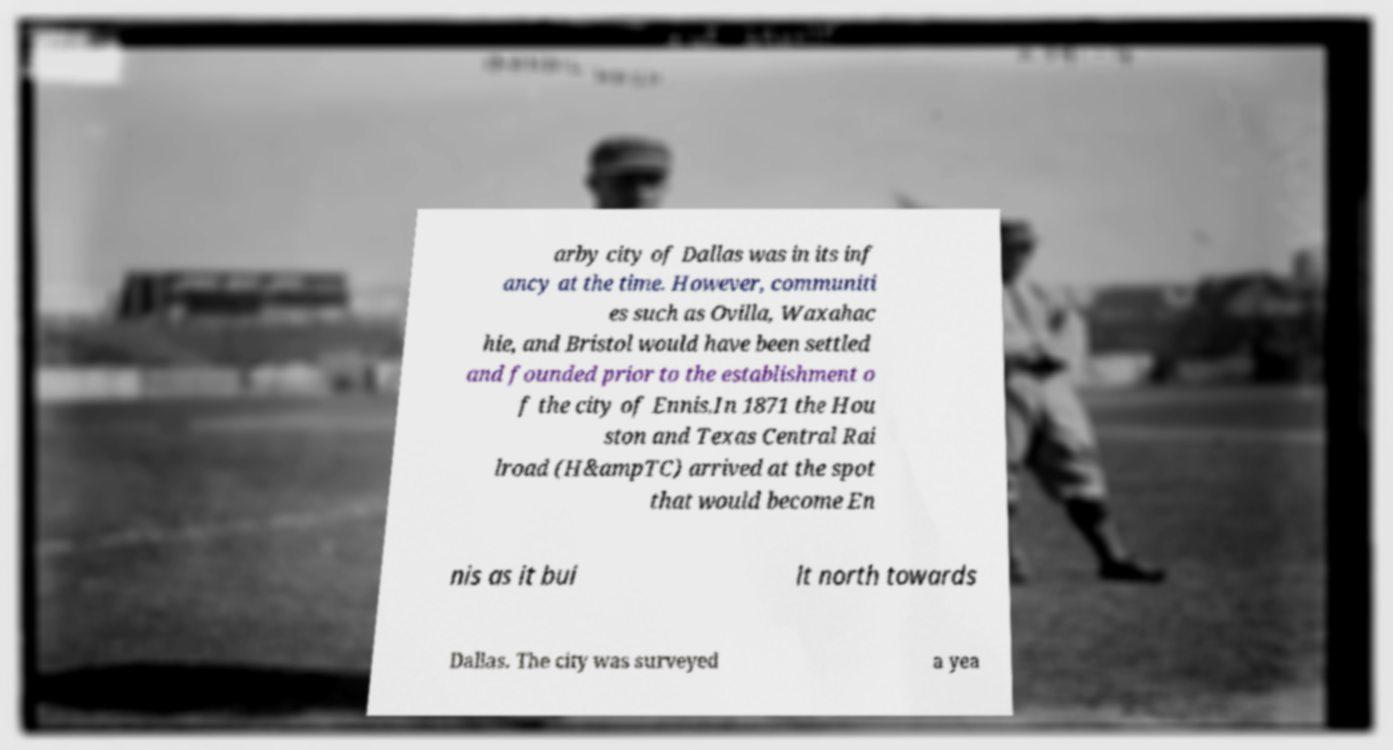Can you accurately transcribe the text from the provided image for me? arby city of Dallas was in its inf ancy at the time. However, communiti es such as Ovilla, Waxahac hie, and Bristol would have been settled and founded prior to the establishment o f the city of Ennis.In 1871 the Hou ston and Texas Central Rai lroad (H&ampTC) arrived at the spot that would become En nis as it bui lt north towards Dallas. The city was surveyed a yea 